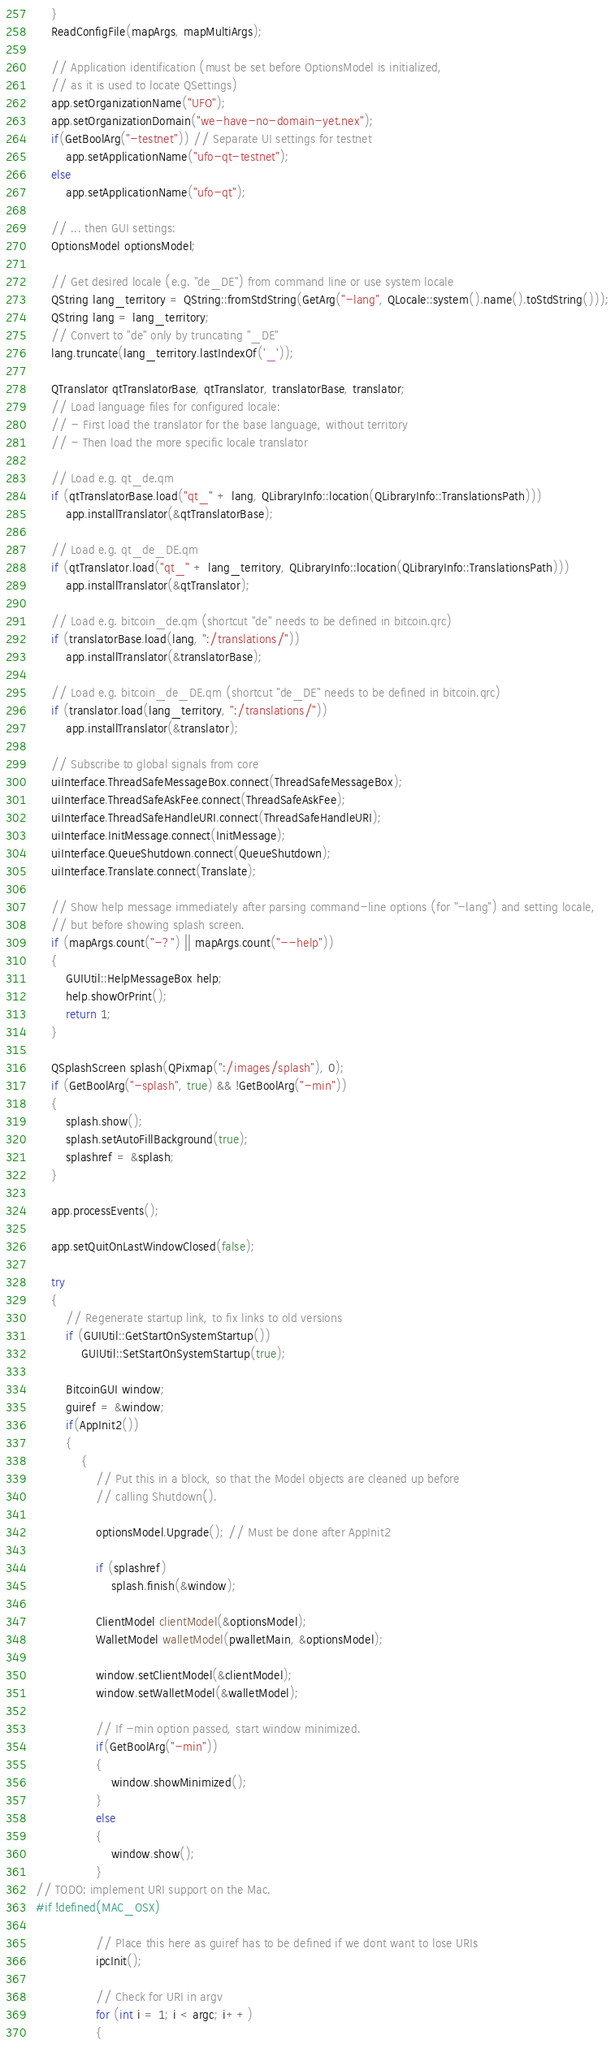Convert code to text. <code><loc_0><loc_0><loc_500><loc_500><_C++_>    }
    ReadConfigFile(mapArgs, mapMultiArgs);

    // Application identification (must be set before OptionsModel is initialized,
    // as it is used to locate QSettings)
    app.setOrganizationName("UFO");
    app.setOrganizationDomain("we-have-no-domain-yet.nex");
    if(GetBoolArg("-testnet")) // Separate UI settings for testnet
        app.setApplicationName("ufo-qt-testnet");
    else
        app.setApplicationName("ufo-qt");

    // ... then GUI settings:
    OptionsModel optionsModel;

    // Get desired locale (e.g. "de_DE") from command line or use system locale
    QString lang_territory = QString::fromStdString(GetArg("-lang", QLocale::system().name().toStdString()));
    QString lang = lang_territory;
    // Convert to "de" only by truncating "_DE"
    lang.truncate(lang_territory.lastIndexOf('_'));

    QTranslator qtTranslatorBase, qtTranslator, translatorBase, translator;
    // Load language files for configured locale:
    // - First load the translator for the base language, without territory
    // - Then load the more specific locale translator

    // Load e.g. qt_de.qm
    if (qtTranslatorBase.load("qt_" + lang, QLibraryInfo::location(QLibraryInfo::TranslationsPath)))
        app.installTranslator(&qtTranslatorBase);

    // Load e.g. qt_de_DE.qm
    if (qtTranslator.load("qt_" + lang_territory, QLibraryInfo::location(QLibraryInfo::TranslationsPath)))
        app.installTranslator(&qtTranslator);

    // Load e.g. bitcoin_de.qm (shortcut "de" needs to be defined in bitcoin.qrc)
    if (translatorBase.load(lang, ":/translations/"))
        app.installTranslator(&translatorBase);

    // Load e.g. bitcoin_de_DE.qm (shortcut "de_DE" needs to be defined in bitcoin.qrc)
    if (translator.load(lang_territory, ":/translations/"))
        app.installTranslator(&translator);

    // Subscribe to global signals from core
    uiInterface.ThreadSafeMessageBox.connect(ThreadSafeMessageBox);
    uiInterface.ThreadSafeAskFee.connect(ThreadSafeAskFee);
    uiInterface.ThreadSafeHandleURI.connect(ThreadSafeHandleURI);
    uiInterface.InitMessage.connect(InitMessage);
    uiInterface.QueueShutdown.connect(QueueShutdown);
    uiInterface.Translate.connect(Translate);

    // Show help message immediately after parsing command-line options (for "-lang") and setting locale,
    // but before showing splash screen.
    if (mapArgs.count("-?") || mapArgs.count("--help"))
    {
        GUIUtil::HelpMessageBox help;
        help.showOrPrint();
        return 1;
    }

    QSplashScreen splash(QPixmap(":/images/splash"), 0);
    if (GetBoolArg("-splash", true) && !GetBoolArg("-min"))
    {
        splash.show();
        splash.setAutoFillBackground(true);
        splashref = &splash;
    }

    app.processEvents();

    app.setQuitOnLastWindowClosed(false);

    try
    {
        // Regenerate startup link, to fix links to old versions
        if (GUIUtil::GetStartOnSystemStartup())
            GUIUtil::SetStartOnSystemStartup(true);

        BitcoinGUI window;
        guiref = &window;
        if(AppInit2())
        {
            {
                // Put this in a block, so that the Model objects are cleaned up before
                // calling Shutdown().

                optionsModel.Upgrade(); // Must be done after AppInit2

                if (splashref)
                    splash.finish(&window);

                ClientModel clientModel(&optionsModel);
                WalletModel walletModel(pwalletMain, &optionsModel);

                window.setClientModel(&clientModel);
                window.setWalletModel(&walletModel);

                // If -min option passed, start window minimized.
                if(GetBoolArg("-min"))
                {
                    window.showMinimized();
                }
                else
                {
                    window.show();
                }
// TODO: implement URI support on the Mac.
#if !defined(MAC_OSX)

                // Place this here as guiref has to be defined if we dont want to lose URIs
                ipcInit();

                // Check for URI in argv
                for (int i = 1; i < argc; i++)
                {</code> 